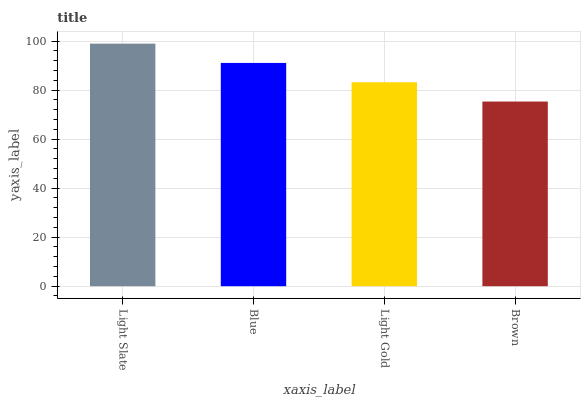Is Brown the minimum?
Answer yes or no. Yes. Is Light Slate the maximum?
Answer yes or no. Yes. Is Blue the minimum?
Answer yes or no. No. Is Blue the maximum?
Answer yes or no. No. Is Light Slate greater than Blue?
Answer yes or no. Yes. Is Blue less than Light Slate?
Answer yes or no. Yes. Is Blue greater than Light Slate?
Answer yes or no. No. Is Light Slate less than Blue?
Answer yes or no. No. Is Blue the high median?
Answer yes or no. Yes. Is Light Gold the low median?
Answer yes or no. Yes. Is Brown the high median?
Answer yes or no. No. Is Blue the low median?
Answer yes or no. No. 